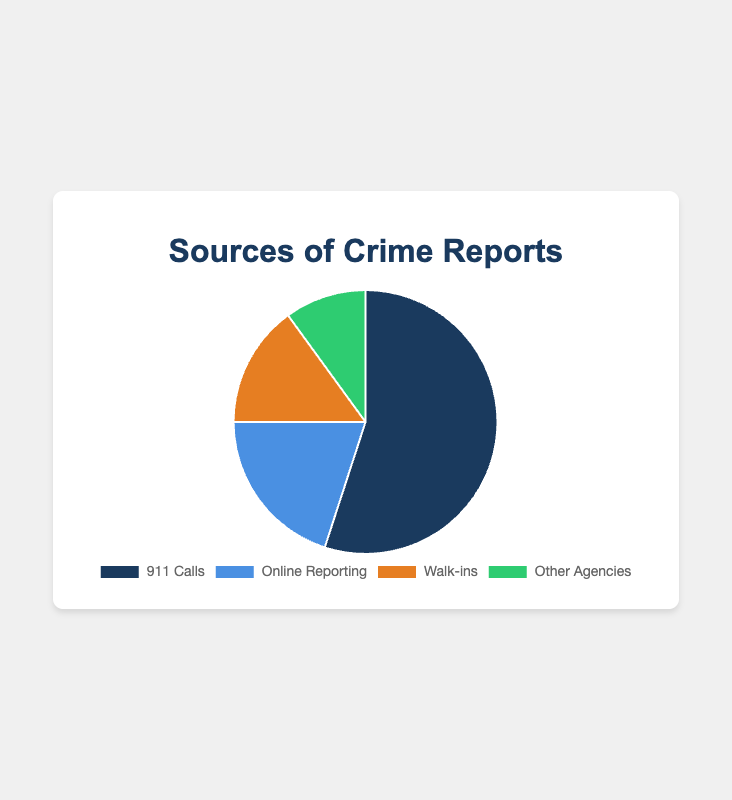Which source has the highest percentage of crime reports? Look at the pie chart and identify the section with the largest percentage. It is labeled "911 Calls" with 55%.
Answer: 911 Calls What's the difference in percentage between 911 Calls and Walk-ins? Subtract the percentage of Walk-ins (15%) from the percentage of 911 Calls (55%). \( 55 - 15 = 40 \)
Answer: 40% How much more common are Online Reporting and Walk-ins combined compared to Other Agencies? Add the percentages of Online Reporting (20%) and Walk-ins (15%) then subtract the percentage of Other Agencies (10%). \( (20 + 15) - 10 = 25 \)
Answer: 25% Which sources of crime reports account for less than 20% each? Look at the sections of the pie chart with percentages less than 20%. These are Walk-ins (15%) and Other Agencies (10%).
Answer: Walk-ins and Other Agencies What's the average percentage for all the sources? Add up all the percentages and then divide by the number of sources. \( (55 + 20 + 15 + 10) / 4 = 100 / 4 = 25 \)
Answer: 25% What is the total percentage represented by Online Reporting and Walk-ins together? Add the percentages of Online Reporting (20%) and Walk-ins (15%). \( 20 + 15 = 35 \)
Answer: 35% Of the four sources, how many sources report at least 15% of crime reports? Count the number of sources with percentages greater than or equal to 15%. These are 911 Calls (55%), Online Reporting (20%), and Walk-ins (15%).
Answer: 3 sources What percentage of crime reports do not come from 911 Calls? Subtract the percentage of 911 Calls from 100%. \( 100 - 55 = 45 \)
Answer: 45% Which source has the smallest percentage of crime reports, and what is that percentage? Identify the section of the pie chart with the smallest percentage. It is labeled "Other Agencies" with 10%.
Answer: Other Agencies, 10% How does the percentage of crime reports from Walk-ins compare to Other Agencies? Subtract the percentage of Other Agencies (10%) from Walk-ins (15%). \( 15 - 10 = 5 \)
Answer: 5% more 